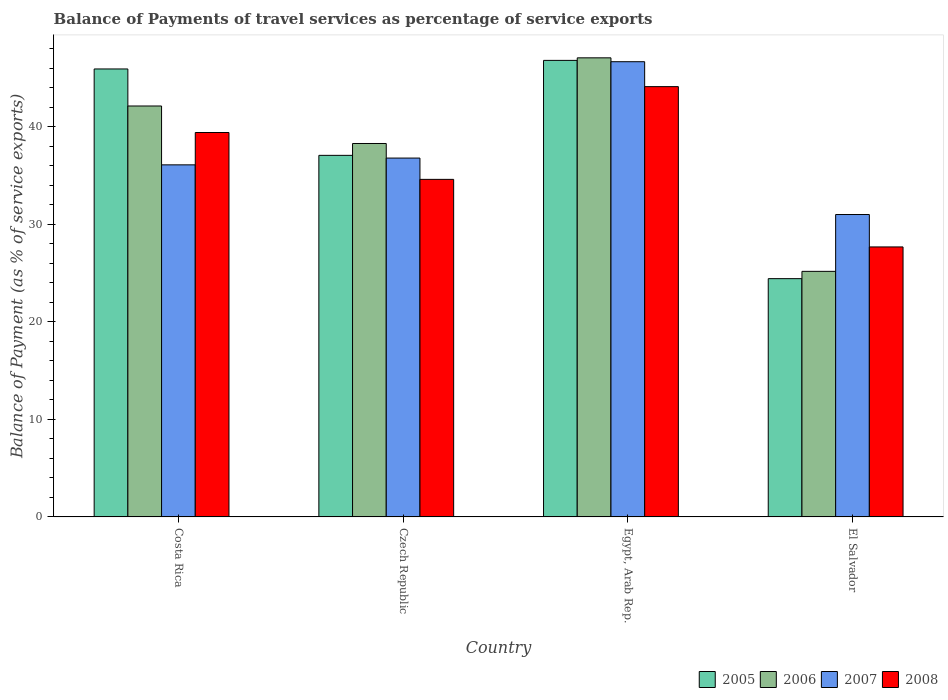How many different coloured bars are there?
Your response must be concise. 4. How many groups of bars are there?
Your answer should be very brief. 4. How many bars are there on the 3rd tick from the left?
Keep it short and to the point. 4. What is the label of the 2nd group of bars from the left?
Offer a very short reply. Czech Republic. In how many cases, is the number of bars for a given country not equal to the number of legend labels?
Provide a succinct answer. 0. What is the balance of payments of travel services in 2008 in El Salvador?
Your answer should be very brief. 27.67. Across all countries, what is the maximum balance of payments of travel services in 2006?
Your answer should be very brief. 47.05. Across all countries, what is the minimum balance of payments of travel services in 2005?
Provide a succinct answer. 24.42. In which country was the balance of payments of travel services in 2008 maximum?
Make the answer very short. Egypt, Arab Rep. In which country was the balance of payments of travel services in 2008 minimum?
Provide a succinct answer. El Salvador. What is the total balance of payments of travel services in 2005 in the graph?
Offer a terse response. 154.16. What is the difference between the balance of payments of travel services in 2006 in Costa Rica and that in Egypt, Arab Rep.?
Provide a short and direct response. -4.94. What is the difference between the balance of payments of travel services in 2005 in Egypt, Arab Rep. and the balance of payments of travel services in 2008 in Costa Rica?
Your answer should be very brief. 7.39. What is the average balance of payments of travel services in 2008 per country?
Your response must be concise. 36.44. What is the difference between the balance of payments of travel services of/in 2005 and balance of payments of travel services of/in 2008 in El Salvador?
Provide a succinct answer. -3.25. In how many countries, is the balance of payments of travel services in 2006 greater than 40 %?
Your answer should be compact. 2. What is the ratio of the balance of payments of travel services in 2005 in Czech Republic to that in Egypt, Arab Rep.?
Your answer should be very brief. 0.79. What is the difference between the highest and the second highest balance of payments of travel services in 2007?
Give a very brief answer. -9.87. What is the difference between the highest and the lowest balance of payments of travel services in 2006?
Ensure brevity in your answer.  21.88. What does the 3rd bar from the left in Czech Republic represents?
Offer a terse response. 2007. What does the 3rd bar from the right in Costa Rica represents?
Your answer should be very brief. 2006. How many bars are there?
Your answer should be compact. 16. Are all the bars in the graph horizontal?
Provide a succinct answer. No. How many countries are there in the graph?
Provide a succinct answer. 4. What is the difference between two consecutive major ticks on the Y-axis?
Offer a very short reply. 10. Are the values on the major ticks of Y-axis written in scientific E-notation?
Give a very brief answer. No. Does the graph contain any zero values?
Provide a succinct answer. No. Does the graph contain grids?
Keep it short and to the point. No. How are the legend labels stacked?
Ensure brevity in your answer.  Horizontal. What is the title of the graph?
Give a very brief answer. Balance of Payments of travel services as percentage of service exports. Does "1994" appear as one of the legend labels in the graph?
Give a very brief answer. No. What is the label or title of the X-axis?
Make the answer very short. Country. What is the label or title of the Y-axis?
Make the answer very short. Balance of Payment (as % of service exports). What is the Balance of Payment (as % of service exports) of 2005 in Costa Rica?
Give a very brief answer. 45.91. What is the Balance of Payment (as % of service exports) of 2006 in Costa Rica?
Provide a short and direct response. 42.11. What is the Balance of Payment (as % of service exports) of 2007 in Costa Rica?
Your answer should be compact. 36.08. What is the Balance of Payment (as % of service exports) in 2008 in Costa Rica?
Offer a terse response. 39.39. What is the Balance of Payment (as % of service exports) in 2005 in Czech Republic?
Your response must be concise. 37.05. What is the Balance of Payment (as % of service exports) in 2006 in Czech Republic?
Provide a short and direct response. 38.27. What is the Balance of Payment (as % of service exports) in 2007 in Czech Republic?
Provide a short and direct response. 36.77. What is the Balance of Payment (as % of service exports) of 2008 in Czech Republic?
Provide a succinct answer. 34.59. What is the Balance of Payment (as % of service exports) of 2005 in Egypt, Arab Rep.?
Provide a succinct answer. 46.79. What is the Balance of Payment (as % of service exports) in 2006 in Egypt, Arab Rep.?
Offer a very short reply. 47.05. What is the Balance of Payment (as % of service exports) of 2007 in Egypt, Arab Rep.?
Your response must be concise. 46.65. What is the Balance of Payment (as % of service exports) of 2008 in Egypt, Arab Rep.?
Keep it short and to the point. 44.09. What is the Balance of Payment (as % of service exports) of 2005 in El Salvador?
Provide a short and direct response. 24.42. What is the Balance of Payment (as % of service exports) in 2006 in El Salvador?
Make the answer very short. 25.17. What is the Balance of Payment (as % of service exports) of 2007 in El Salvador?
Offer a very short reply. 30.99. What is the Balance of Payment (as % of service exports) in 2008 in El Salvador?
Your answer should be very brief. 27.67. Across all countries, what is the maximum Balance of Payment (as % of service exports) in 2005?
Provide a succinct answer. 46.79. Across all countries, what is the maximum Balance of Payment (as % of service exports) in 2006?
Make the answer very short. 47.05. Across all countries, what is the maximum Balance of Payment (as % of service exports) of 2007?
Offer a terse response. 46.65. Across all countries, what is the maximum Balance of Payment (as % of service exports) of 2008?
Make the answer very short. 44.09. Across all countries, what is the minimum Balance of Payment (as % of service exports) of 2005?
Provide a succinct answer. 24.42. Across all countries, what is the minimum Balance of Payment (as % of service exports) in 2006?
Make the answer very short. 25.17. Across all countries, what is the minimum Balance of Payment (as % of service exports) of 2007?
Offer a terse response. 30.99. Across all countries, what is the minimum Balance of Payment (as % of service exports) in 2008?
Your answer should be very brief. 27.67. What is the total Balance of Payment (as % of service exports) in 2005 in the graph?
Ensure brevity in your answer.  154.16. What is the total Balance of Payment (as % of service exports) of 2006 in the graph?
Provide a short and direct response. 152.59. What is the total Balance of Payment (as % of service exports) of 2007 in the graph?
Provide a succinct answer. 150.49. What is the total Balance of Payment (as % of service exports) of 2008 in the graph?
Ensure brevity in your answer.  145.75. What is the difference between the Balance of Payment (as % of service exports) in 2005 in Costa Rica and that in Czech Republic?
Make the answer very short. 8.85. What is the difference between the Balance of Payment (as % of service exports) of 2006 in Costa Rica and that in Czech Republic?
Give a very brief answer. 3.84. What is the difference between the Balance of Payment (as % of service exports) in 2007 in Costa Rica and that in Czech Republic?
Your answer should be very brief. -0.69. What is the difference between the Balance of Payment (as % of service exports) of 2008 in Costa Rica and that in Czech Republic?
Give a very brief answer. 4.8. What is the difference between the Balance of Payment (as % of service exports) in 2005 in Costa Rica and that in Egypt, Arab Rep.?
Offer a terse response. -0.88. What is the difference between the Balance of Payment (as % of service exports) in 2006 in Costa Rica and that in Egypt, Arab Rep.?
Make the answer very short. -4.94. What is the difference between the Balance of Payment (as % of service exports) of 2007 in Costa Rica and that in Egypt, Arab Rep.?
Make the answer very short. -10.57. What is the difference between the Balance of Payment (as % of service exports) of 2008 in Costa Rica and that in Egypt, Arab Rep.?
Keep it short and to the point. -4.7. What is the difference between the Balance of Payment (as % of service exports) in 2005 in Costa Rica and that in El Salvador?
Make the answer very short. 21.49. What is the difference between the Balance of Payment (as % of service exports) in 2006 in Costa Rica and that in El Salvador?
Make the answer very short. 16.95. What is the difference between the Balance of Payment (as % of service exports) of 2007 in Costa Rica and that in El Salvador?
Provide a succinct answer. 5.09. What is the difference between the Balance of Payment (as % of service exports) in 2008 in Costa Rica and that in El Salvador?
Offer a terse response. 11.73. What is the difference between the Balance of Payment (as % of service exports) of 2005 in Czech Republic and that in Egypt, Arab Rep.?
Your answer should be compact. -9.73. What is the difference between the Balance of Payment (as % of service exports) in 2006 in Czech Republic and that in Egypt, Arab Rep.?
Make the answer very short. -8.78. What is the difference between the Balance of Payment (as % of service exports) of 2007 in Czech Republic and that in Egypt, Arab Rep.?
Provide a short and direct response. -9.87. What is the difference between the Balance of Payment (as % of service exports) of 2008 in Czech Republic and that in Egypt, Arab Rep.?
Your answer should be very brief. -9.5. What is the difference between the Balance of Payment (as % of service exports) in 2005 in Czech Republic and that in El Salvador?
Keep it short and to the point. 12.64. What is the difference between the Balance of Payment (as % of service exports) of 2006 in Czech Republic and that in El Salvador?
Offer a terse response. 13.1. What is the difference between the Balance of Payment (as % of service exports) in 2007 in Czech Republic and that in El Salvador?
Your response must be concise. 5.78. What is the difference between the Balance of Payment (as % of service exports) of 2008 in Czech Republic and that in El Salvador?
Make the answer very short. 6.92. What is the difference between the Balance of Payment (as % of service exports) in 2005 in Egypt, Arab Rep. and that in El Salvador?
Offer a very short reply. 22.37. What is the difference between the Balance of Payment (as % of service exports) in 2006 in Egypt, Arab Rep. and that in El Salvador?
Keep it short and to the point. 21.88. What is the difference between the Balance of Payment (as % of service exports) of 2007 in Egypt, Arab Rep. and that in El Salvador?
Offer a terse response. 15.66. What is the difference between the Balance of Payment (as % of service exports) in 2008 in Egypt, Arab Rep. and that in El Salvador?
Ensure brevity in your answer.  16.43. What is the difference between the Balance of Payment (as % of service exports) of 2005 in Costa Rica and the Balance of Payment (as % of service exports) of 2006 in Czech Republic?
Offer a terse response. 7.64. What is the difference between the Balance of Payment (as % of service exports) in 2005 in Costa Rica and the Balance of Payment (as % of service exports) in 2007 in Czech Republic?
Your answer should be very brief. 9.13. What is the difference between the Balance of Payment (as % of service exports) of 2005 in Costa Rica and the Balance of Payment (as % of service exports) of 2008 in Czech Republic?
Your answer should be very brief. 11.31. What is the difference between the Balance of Payment (as % of service exports) in 2006 in Costa Rica and the Balance of Payment (as % of service exports) in 2007 in Czech Republic?
Offer a terse response. 5.34. What is the difference between the Balance of Payment (as % of service exports) of 2006 in Costa Rica and the Balance of Payment (as % of service exports) of 2008 in Czech Republic?
Offer a very short reply. 7.52. What is the difference between the Balance of Payment (as % of service exports) of 2007 in Costa Rica and the Balance of Payment (as % of service exports) of 2008 in Czech Republic?
Your answer should be very brief. 1.49. What is the difference between the Balance of Payment (as % of service exports) in 2005 in Costa Rica and the Balance of Payment (as % of service exports) in 2006 in Egypt, Arab Rep.?
Make the answer very short. -1.14. What is the difference between the Balance of Payment (as % of service exports) of 2005 in Costa Rica and the Balance of Payment (as % of service exports) of 2007 in Egypt, Arab Rep.?
Offer a terse response. -0.74. What is the difference between the Balance of Payment (as % of service exports) in 2005 in Costa Rica and the Balance of Payment (as % of service exports) in 2008 in Egypt, Arab Rep.?
Your response must be concise. 1.81. What is the difference between the Balance of Payment (as % of service exports) in 2006 in Costa Rica and the Balance of Payment (as % of service exports) in 2007 in Egypt, Arab Rep.?
Offer a very short reply. -4.54. What is the difference between the Balance of Payment (as % of service exports) of 2006 in Costa Rica and the Balance of Payment (as % of service exports) of 2008 in Egypt, Arab Rep.?
Give a very brief answer. -1.98. What is the difference between the Balance of Payment (as % of service exports) in 2007 in Costa Rica and the Balance of Payment (as % of service exports) in 2008 in Egypt, Arab Rep.?
Offer a very short reply. -8.01. What is the difference between the Balance of Payment (as % of service exports) of 2005 in Costa Rica and the Balance of Payment (as % of service exports) of 2006 in El Salvador?
Offer a very short reply. 20.74. What is the difference between the Balance of Payment (as % of service exports) of 2005 in Costa Rica and the Balance of Payment (as % of service exports) of 2007 in El Salvador?
Ensure brevity in your answer.  14.92. What is the difference between the Balance of Payment (as % of service exports) of 2005 in Costa Rica and the Balance of Payment (as % of service exports) of 2008 in El Salvador?
Give a very brief answer. 18.24. What is the difference between the Balance of Payment (as % of service exports) of 2006 in Costa Rica and the Balance of Payment (as % of service exports) of 2007 in El Salvador?
Your answer should be very brief. 11.12. What is the difference between the Balance of Payment (as % of service exports) of 2006 in Costa Rica and the Balance of Payment (as % of service exports) of 2008 in El Salvador?
Make the answer very short. 14.44. What is the difference between the Balance of Payment (as % of service exports) in 2007 in Costa Rica and the Balance of Payment (as % of service exports) in 2008 in El Salvador?
Your answer should be compact. 8.41. What is the difference between the Balance of Payment (as % of service exports) in 2005 in Czech Republic and the Balance of Payment (as % of service exports) in 2006 in Egypt, Arab Rep.?
Offer a very short reply. -9.99. What is the difference between the Balance of Payment (as % of service exports) in 2005 in Czech Republic and the Balance of Payment (as % of service exports) in 2007 in Egypt, Arab Rep.?
Provide a short and direct response. -9.59. What is the difference between the Balance of Payment (as % of service exports) of 2005 in Czech Republic and the Balance of Payment (as % of service exports) of 2008 in Egypt, Arab Rep.?
Your answer should be very brief. -7.04. What is the difference between the Balance of Payment (as % of service exports) of 2006 in Czech Republic and the Balance of Payment (as % of service exports) of 2007 in Egypt, Arab Rep.?
Provide a short and direct response. -8.38. What is the difference between the Balance of Payment (as % of service exports) of 2006 in Czech Republic and the Balance of Payment (as % of service exports) of 2008 in Egypt, Arab Rep.?
Your answer should be very brief. -5.83. What is the difference between the Balance of Payment (as % of service exports) of 2007 in Czech Republic and the Balance of Payment (as % of service exports) of 2008 in Egypt, Arab Rep.?
Ensure brevity in your answer.  -7.32. What is the difference between the Balance of Payment (as % of service exports) of 2005 in Czech Republic and the Balance of Payment (as % of service exports) of 2006 in El Salvador?
Ensure brevity in your answer.  11.89. What is the difference between the Balance of Payment (as % of service exports) in 2005 in Czech Republic and the Balance of Payment (as % of service exports) in 2007 in El Salvador?
Offer a terse response. 6.06. What is the difference between the Balance of Payment (as % of service exports) in 2005 in Czech Republic and the Balance of Payment (as % of service exports) in 2008 in El Salvador?
Give a very brief answer. 9.39. What is the difference between the Balance of Payment (as % of service exports) in 2006 in Czech Republic and the Balance of Payment (as % of service exports) in 2007 in El Salvador?
Your answer should be very brief. 7.28. What is the difference between the Balance of Payment (as % of service exports) of 2006 in Czech Republic and the Balance of Payment (as % of service exports) of 2008 in El Salvador?
Your answer should be compact. 10.6. What is the difference between the Balance of Payment (as % of service exports) in 2007 in Czech Republic and the Balance of Payment (as % of service exports) in 2008 in El Salvador?
Make the answer very short. 9.11. What is the difference between the Balance of Payment (as % of service exports) of 2005 in Egypt, Arab Rep. and the Balance of Payment (as % of service exports) of 2006 in El Salvador?
Provide a succinct answer. 21.62. What is the difference between the Balance of Payment (as % of service exports) in 2005 in Egypt, Arab Rep. and the Balance of Payment (as % of service exports) in 2007 in El Salvador?
Give a very brief answer. 15.8. What is the difference between the Balance of Payment (as % of service exports) of 2005 in Egypt, Arab Rep. and the Balance of Payment (as % of service exports) of 2008 in El Salvador?
Give a very brief answer. 19.12. What is the difference between the Balance of Payment (as % of service exports) of 2006 in Egypt, Arab Rep. and the Balance of Payment (as % of service exports) of 2007 in El Salvador?
Your response must be concise. 16.06. What is the difference between the Balance of Payment (as % of service exports) of 2006 in Egypt, Arab Rep. and the Balance of Payment (as % of service exports) of 2008 in El Salvador?
Give a very brief answer. 19.38. What is the difference between the Balance of Payment (as % of service exports) in 2007 in Egypt, Arab Rep. and the Balance of Payment (as % of service exports) in 2008 in El Salvador?
Make the answer very short. 18.98. What is the average Balance of Payment (as % of service exports) in 2005 per country?
Give a very brief answer. 38.54. What is the average Balance of Payment (as % of service exports) of 2006 per country?
Provide a succinct answer. 38.15. What is the average Balance of Payment (as % of service exports) in 2007 per country?
Your answer should be very brief. 37.62. What is the average Balance of Payment (as % of service exports) in 2008 per country?
Ensure brevity in your answer.  36.44. What is the difference between the Balance of Payment (as % of service exports) of 2005 and Balance of Payment (as % of service exports) of 2006 in Costa Rica?
Offer a terse response. 3.8. What is the difference between the Balance of Payment (as % of service exports) of 2005 and Balance of Payment (as % of service exports) of 2007 in Costa Rica?
Ensure brevity in your answer.  9.83. What is the difference between the Balance of Payment (as % of service exports) in 2005 and Balance of Payment (as % of service exports) in 2008 in Costa Rica?
Give a very brief answer. 6.51. What is the difference between the Balance of Payment (as % of service exports) in 2006 and Balance of Payment (as % of service exports) in 2007 in Costa Rica?
Your answer should be very brief. 6.03. What is the difference between the Balance of Payment (as % of service exports) in 2006 and Balance of Payment (as % of service exports) in 2008 in Costa Rica?
Give a very brief answer. 2.72. What is the difference between the Balance of Payment (as % of service exports) of 2007 and Balance of Payment (as % of service exports) of 2008 in Costa Rica?
Ensure brevity in your answer.  -3.31. What is the difference between the Balance of Payment (as % of service exports) of 2005 and Balance of Payment (as % of service exports) of 2006 in Czech Republic?
Ensure brevity in your answer.  -1.22. What is the difference between the Balance of Payment (as % of service exports) in 2005 and Balance of Payment (as % of service exports) in 2007 in Czech Republic?
Keep it short and to the point. 0.28. What is the difference between the Balance of Payment (as % of service exports) in 2005 and Balance of Payment (as % of service exports) in 2008 in Czech Republic?
Make the answer very short. 2.46. What is the difference between the Balance of Payment (as % of service exports) in 2006 and Balance of Payment (as % of service exports) in 2007 in Czech Republic?
Offer a terse response. 1.5. What is the difference between the Balance of Payment (as % of service exports) in 2006 and Balance of Payment (as % of service exports) in 2008 in Czech Republic?
Offer a very short reply. 3.68. What is the difference between the Balance of Payment (as % of service exports) in 2007 and Balance of Payment (as % of service exports) in 2008 in Czech Republic?
Offer a very short reply. 2.18. What is the difference between the Balance of Payment (as % of service exports) of 2005 and Balance of Payment (as % of service exports) of 2006 in Egypt, Arab Rep.?
Provide a succinct answer. -0.26. What is the difference between the Balance of Payment (as % of service exports) of 2005 and Balance of Payment (as % of service exports) of 2007 in Egypt, Arab Rep.?
Offer a terse response. 0.14. What is the difference between the Balance of Payment (as % of service exports) of 2005 and Balance of Payment (as % of service exports) of 2008 in Egypt, Arab Rep.?
Offer a terse response. 2.69. What is the difference between the Balance of Payment (as % of service exports) in 2006 and Balance of Payment (as % of service exports) in 2007 in Egypt, Arab Rep.?
Your answer should be compact. 0.4. What is the difference between the Balance of Payment (as % of service exports) in 2006 and Balance of Payment (as % of service exports) in 2008 in Egypt, Arab Rep.?
Your answer should be compact. 2.95. What is the difference between the Balance of Payment (as % of service exports) in 2007 and Balance of Payment (as % of service exports) in 2008 in Egypt, Arab Rep.?
Ensure brevity in your answer.  2.55. What is the difference between the Balance of Payment (as % of service exports) of 2005 and Balance of Payment (as % of service exports) of 2006 in El Salvador?
Keep it short and to the point. -0.75. What is the difference between the Balance of Payment (as % of service exports) in 2005 and Balance of Payment (as % of service exports) in 2007 in El Salvador?
Offer a very short reply. -6.57. What is the difference between the Balance of Payment (as % of service exports) in 2005 and Balance of Payment (as % of service exports) in 2008 in El Salvador?
Offer a terse response. -3.25. What is the difference between the Balance of Payment (as % of service exports) in 2006 and Balance of Payment (as % of service exports) in 2007 in El Salvador?
Offer a very short reply. -5.82. What is the difference between the Balance of Payment (as % of service exports) in 2006 and Balance of Payment (as % of service exports) in 2008 in El Salvador?
Give a very brief answer. -2.5. What is the difference between the Balance of Payment (as % of service exports) of 2007 and Balance of Payment (as % of service exports) of 2008 in El Salvador?
Your answer should be compact. 3.32. What is the ratio of the Balance of Payment (as % of service exports) in 2005 in Costa Rica to that in Czech Republic?
Ensure brevity in your answer.  1.24. What is the ratio of the Balance of Payment (as % of service exports) of 2006 in Costa Rica to that in Czech Republic?
Ensure brevity in your answer.  1.1. What is the ratio of the Balance of Payment (as % of service exports) of 2007 in Costa Rica to that in Czech Republic?
Your answer should be compact. 0.98. What is the ratio of the Balance of Payment (as % of service exports) in 2008 in Costa Rica to that in Czech Republic?
Make the answer very short. 1.14. What is the ratio of the Balance of Payment (as % of service exports) in 2005 in Costa Rica to that in Egypt, Arab Rep.?
Provide a succinct answer. 0.98. What is the ratio of the Balance of Payment (as % of service exports) of 2006 in Costa Rica to that in Egypt, Arab Rep.?
Your answer should be very brief. 0.9. What is the ratio of the Balance of Payment (as % of service exports) in 2007 in Costa Rica to that in Egypt, Arab Rep.?
Make the answer very short. 0.77. What is the ratio of the Balance of Payment (as % of service exports) of 2008 in Costa Rica to that in Egypt, Arab Rep.?
Provide a succinct answer. 0.89. What is the ratio of the Balance of Payment (as % of service exports) of 2005 in Costa Rica to that in El Salvador?
Ensure brevity in your answer.  1.88. What is the ratio of the Balance of Payment (as % of service exports) of 2006 in Costa Rica to that in El Salvador?
Provide a short and direct response. 1.67. What is the ratio of the Balance of Payment (as % of service exports) in 2007 in Costa Rica to that in El Salvador?
Provide a short and direct response. 1.16. What is the ratio of the Balance of Payment (as % of service exports) in 2008 in Costa Rica to that in El Salvador?
Make the answer very short. 1.42. What is the ratio of the Balance of Payment (as % of service exports) of 2005 in Czech Republic to that in Egypt, Arab Rep.?
Provide a succinct answer. 0.79. What is the ratio of the Balance of Payment (as % of service exports) of 2006 in Czech Republic to that in Egypt, Arab Rep.?
Your answer should be very brief. 0.81. What is the ratio of the Balance of Payment (as % of service exports) in 2007 in Czech Republic to that in Egypt, Arab Rep.?
Your answer should be compact. 0.79. What is the ratio of the Balance of Payment (as % of service exports) of 2008 in Czech Republic to that in Egypt, Arab Rep.?
Ensure brevity in your answer.  0.78. What is the ratio of the Balance of Payment (as % of service exports) of 2005 in Czech Republic to that in El Salvador?
Your answer should be very brief. 1.52. What is the ratio of the Balance of Payment (as % of service exports) in 2006 in Czech Republic to that in El Salvador?
Your answer should be compact. 1.52. What is the ratio of the Balance of Payment (as % of service exports) of 2007 in Czech Republic to that in El Salvador?
Ensure brevity in your answer.  1.19. What is the ratio of the Balance of Payment (as % of service exports) in 2008 in Czech Republic to that in El Salvador?
Offer a terse response. 1.25. What is the ratio of the Balance of Payment (as % of service exports) in 2005 in Egypt, Arab Rep. to that in El Salvador?
Provide a succinct answer. 1.92. What is the ratio of the Balance of Payment (as % of service exports) in 2006 in Egypt, Arab Rep. to that in El Salvador?
Provide a succinct answer. 1.87. What is the ratio of the Balance of Payment (as % of service exports) in 2007 in Egypt, Arab Rep. to that in El Salvador?
Your answer should be very brief. 1.51. What is the ratio of the Balance of Payment (as % of service exports) of 2008 in Egypt, Arab Rep. to that in El Salvador?
Your answer should be compact. 1.59. What is the difference between the highest and the second highest Balance of Payment (as % of service exports) of 2005?
Your response must be concise. 0.88. What is the difference between the highest and the second highest Balance of Payment (as % of service exports) in 2006?
Provide a succinct answer. 4.94. What is the difference between the highest and the second highest Balance of Payment (as % of service exports) in 2007?
Make the answer very short. 9.87. What is the difference between the highest and the second highest Balance of Payment (as % of service exports) in 2008?
Make the answer very short. 4.7. What is the difference between the highest and the lowest Balance of Payment (as % of service exports) of 2005?
Keep it short and to the point. 22.37. What is the difference between the highest and the lowest Balance of Payment (as % of service exports) of 2006?
Make the answer very short. 21.88. What is the difference between the highest and the lowest Balance of Payment (as % of service exports) in 2007?
Your answer should be compact. 15.66. What is the difference between the highest and the lowest Balance of Payment (as % of service exports) of 2008?
Ensure brevity in your answer.  16.43. 